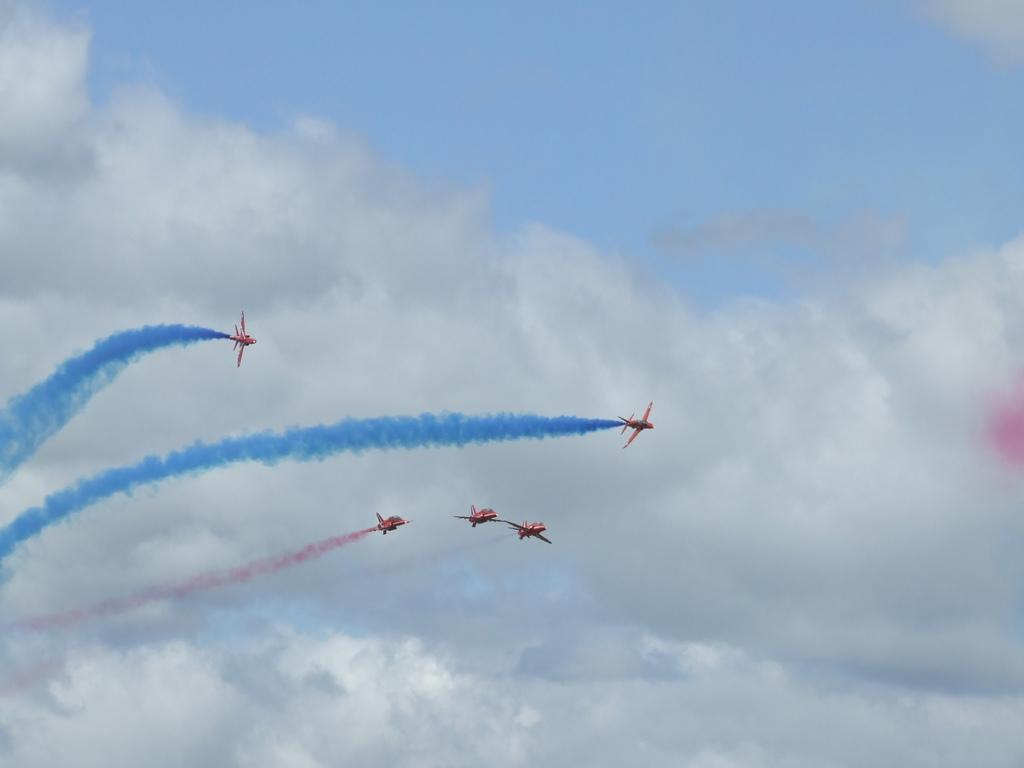What is the main subject of the image? The main subject of the image is aeroplanes. What are the aeroplanes doing in the image? The aeroplanes are flying in the sky. What is a unique feature of the aeroplanes in the image? The aeroplanes are releasing blue and pink smoke. What else can be seen in the sky in the image? There are clouds visible in the image. What type of food is being traded between the aeroplanes in the image? There is no indication in the image that the aeroplanes are trading food or any other items. What type of carriage is being pulled by the aeroplanes in the image? There is no carriage present in the image; it features aeroplanes flying in the sky and releasing blue and pink smoke. 